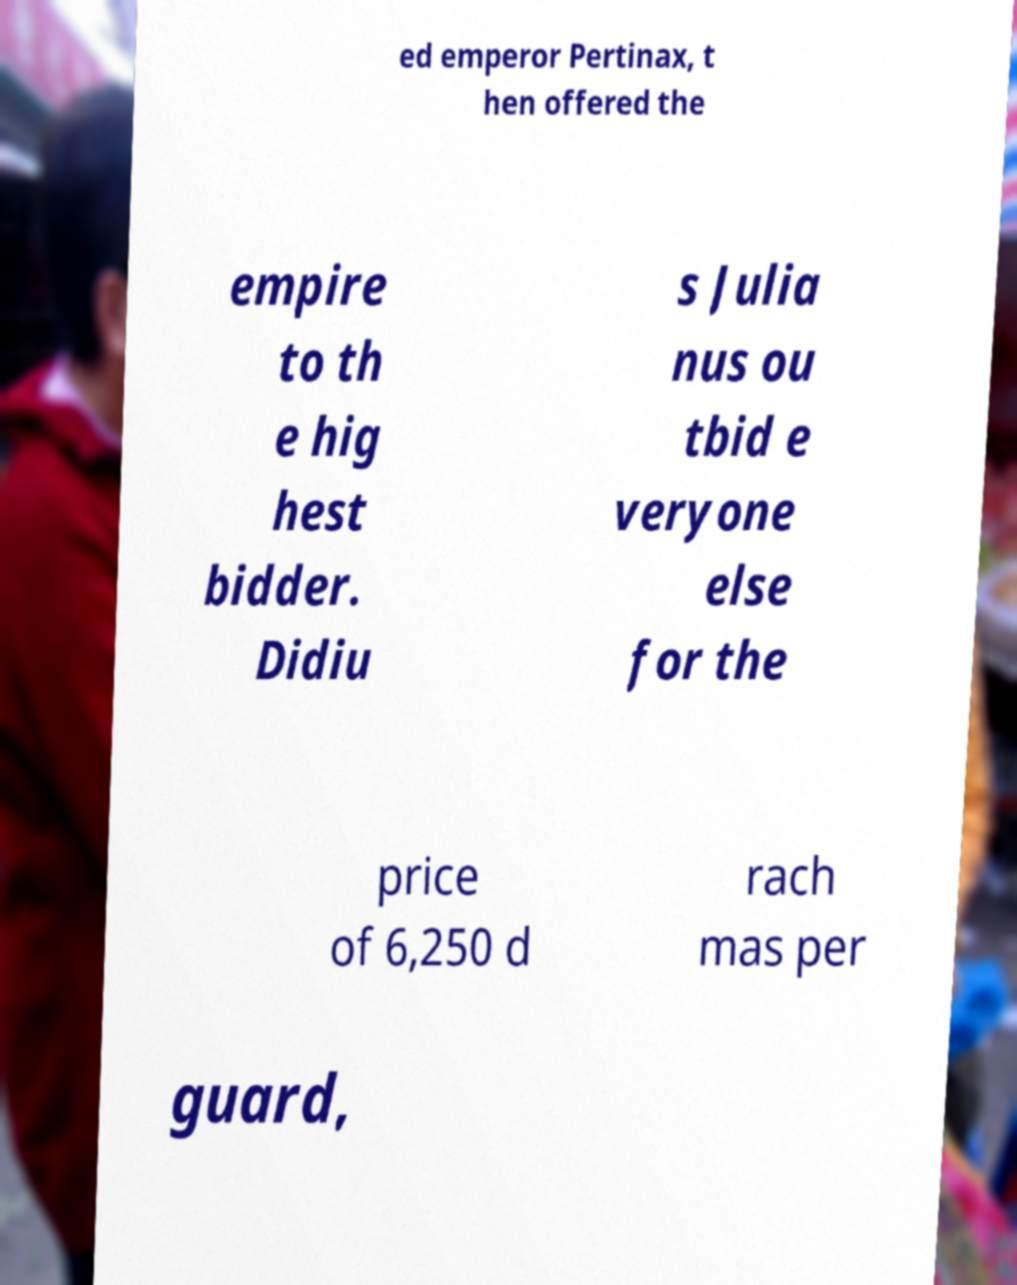There's text embedded in this image that I need extracted. Can you transcribe it verbatim? ed emperor Pertinax, t hen offered the empire to th e hig hest bidder. Didiu s Julia nus ou tbid e veryone else for the price of 6,250 d rach mas per guard, 